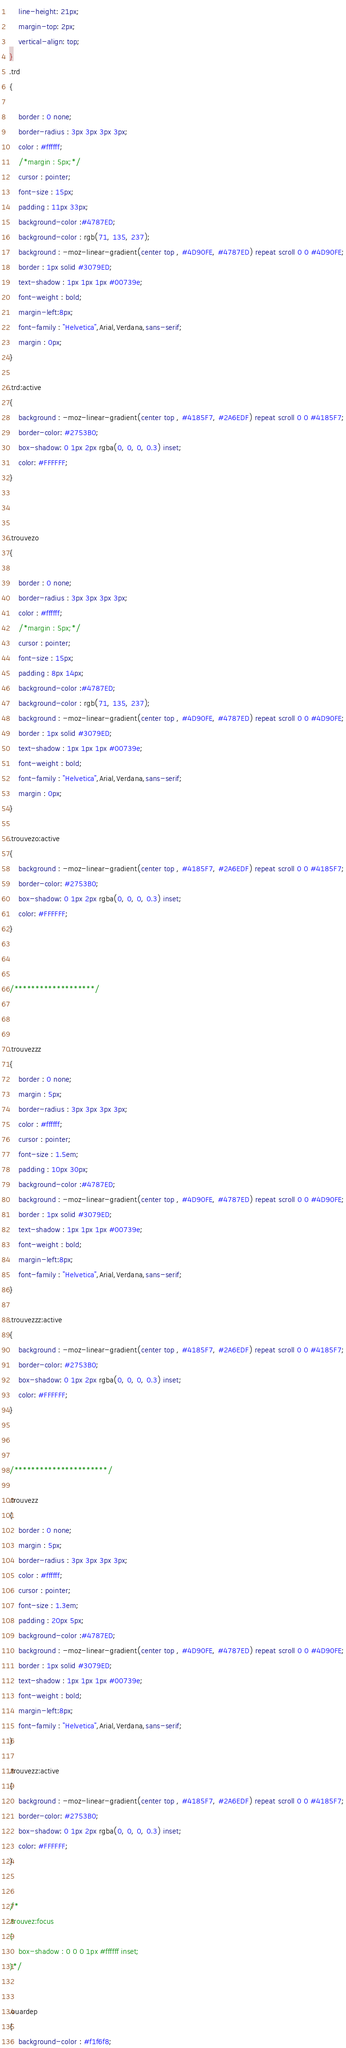<code> <loc_0><loc_0><loc_500><loc_500><_CSS_>    line-height: 21px;
    margin-top: 2px;
    vertical-align: top;
}
.trd
{
	
	border : 0 none;
	border-radius : 3px 3px 3px 3px;
	color : #ffffff;
	/*margin : 5px;*/
	cursor : pointer;
	font-size : 15px;
	padding : 11px 33px;
	background-color :#4787ED;
	background-color : rgb(71, 135, 237);
	background : -moz-linear-gradient(center top , #4D90FE, #4787ED) repeat scroll 0 0 #4D90FE;
	border : 1px solid #3079ED;
	text-shadow : 1px 1px 1px #00739e;
	font-weight : bold;
	margin-left:8px;
	font-family : "Helvetica",Arial,Verdana,sans-serif;
	margin : 0px;
}

.trd:active
{
	background : -moz-linear-gradient(center top , #4185F7, #2A6EDF) repeat scroll 0 0 #4185F7;
    border-color: #2753B0;
    box-shadow: 0 1px 2px rgba(0, 0, 0, 0.3) inset;
    color: #FFFFFF;
}



.trouvezo
{
	
	border : 0 none;
	border-radius : 3px 3px 3px 3px;
	color : #ffffff;
	/*margin : 5px;*/
	cursor : pointer;
	font-size : 15px;
	padding : 8px 14px;
	background-color :#4787ED;
	background-color : rgb(71, 135, 237);
	background : -moz-linear-gradient(center top , #4D90FE, #4787ED) repeat scroll 0 0 #4D90FE;
	border : 1px solid #3079ED;
	text-shadow : 1px 1px 1px #00739e;
	font-weight : bold;
	font-family : "Helvetica",Arial,Verdana,sans-serif;
	margin : 0px;
}

.trouvezo:active
{
	background : -moz-linear-gradient(center top , #4185F7, #2A6EDF) repeat scroll 0 0 #4185F7;
    border-color: #2753B0;
    box-shadow: 0 1px 2px rgba(0, 0, 0, 0.3) inset;
    color: #FFFFFF;
}



/*******************/



.trouvezzz
{
	border : 0 none;
	margin : 5px;
	border-radius : 3px 3px 3px 3px;
	color : #ffffff;
	cursor : pointer;
	font-size : 1.5em;
	padding : 10px 30px;
	background-color :#4787ED;
	background : -moz-linear-gradient(center top , #4D90FE, #4787ED) repeat scroll 0 0 #4D90FE;
	border : 1px solid #3079ED;
	text-shadow : 1px 1px 1px #00739e;
	font-weight : bold;
	margin-left:8px;
	font-family : "Helvetica",Arial,Verdana,sans-serif;
}

.trouvezzz:active
{
	background : -moz-linear-gradient(center top , #4185F7, #2A6EDF) repeat scroll 0 0 #4185F7;
    border-color: #2753B0;
    box-shadow: 0 1px 2px rgba(0, 0, 0, 0.3) inset;
    color: #FFFFFF;
}



/**********************/

.trouvezz
{
	border : 0 none;
	margin : 5px;
	border-radius : 3px 3px 3px 3px;
	color : #ffffff;
	cursor : pointer;
	font-size : 1.3em;
	padding : 20px 5px;
	background-color :#4787ED;
	background : -moz-linear-gradient(center top , #4D90FE, #4787ED) repeat scroll 0 0 #4D90FE;
	border : 1px solid #3079ED;
	text-shadow : 1px 1px 1px #00739e;
	font-weight : bold;
	margin-left:8px;
	font-family : "Helvetica",Arial,Verdana,sans-serif;
}

.trouvezz:active
{
	background : -moz-linear-gradient(center top , #4185F7, #2A6EDF) repeat scroll 0 0 #4185F7;
    border-color: #2753B0;
    box-shadow: 0 1px 2px rgba(0, 0, 0, 0.3) inset;
    color: #FFFFFF;
}


/*
.trouvez:focus 
{
	box-shadow : 0 0 0 1px #ffffff inset;
}*/


.ouardep
{
	background-color : #f1f6f8;</code> 